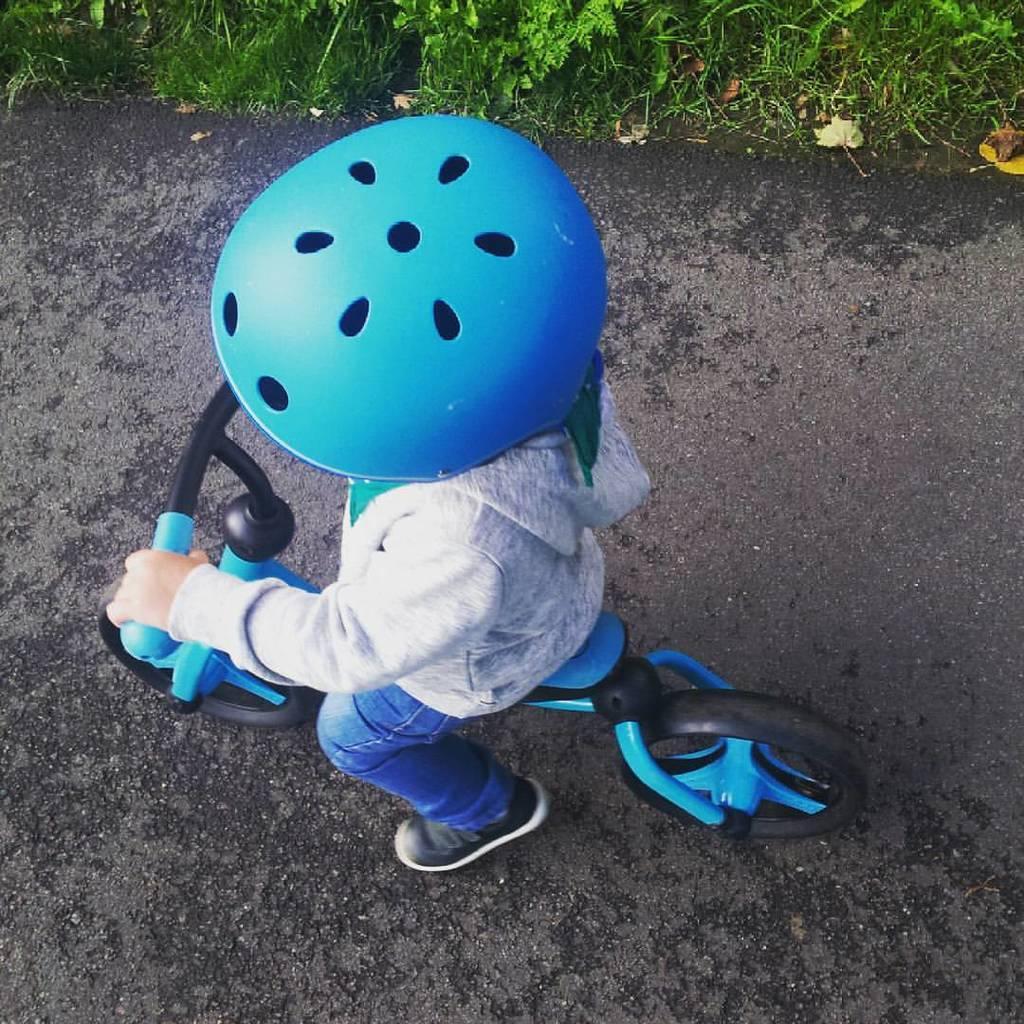Please provide a concise description of this image. In this image we can see a kid sitting on the bicycle wearing a helmet on the road. In the background we can see grass and shredded leaves. 